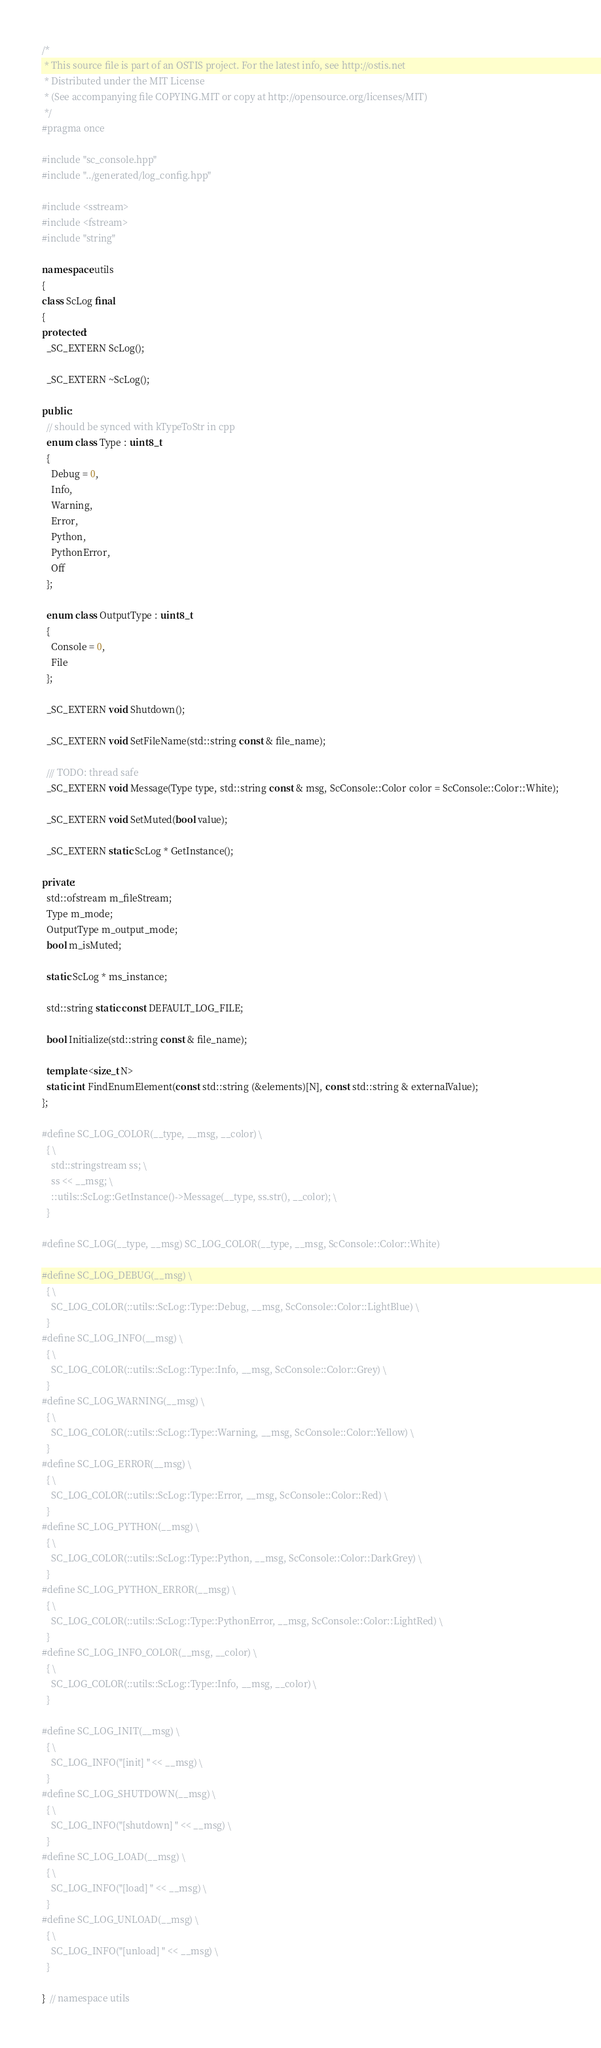<code> <loc_0><loc_0><loc_500><loc_500><_C++_>/*
 * This source file is part of an OSTIS project. For the latest info, see http://ostis.net
 * Distributed under the MIT License
 * (See accompanying file COPYING.MIT or copy at http://opensource.org/licenses/MIT)
 */
#pragma once

#include "sc_console.hpp"
#include "../generated/log_config.hpp"

#include <sstream>
#include <fstream>
#include "string"

namespace utils
{
class ScLog final
{
protected:
  _SC_EXTERN ScLog();

  _SC_EXTERN ~ScLog();

public:
  // should be synced with kTypeToStr in cpp
  enum class Type : uint8_t
  {
    Debug = 0,
    Info,
    Warning,
    Error,
    Python,
    PythonError,
    Off
  };

  enum class OutputType : uint8_t
  {
    Console = 0,
    File
  };

  _SC_EXTERN void Shutdown();

  _SC_EXTERN void SetFileName(std::string const & file_name);

  /// TODO: thread safe
  _SC_EXTERN void Message(Type type, std::string const & msg, ScConsole::Color color = ScConsole::Color::White);

  _SC_EXTERN void SetMuted(bool value);

  _SC_EXTERN static ScLog * GetInstance();

private:
  std::ofstream m_fileStream;
  Type m_mode;
  OutputType m_output_mode;
  bool m_isMuted;

  static ScLog * ms_instance;

  std::string static const DEFAULT_LOG_FILE;

  bool Initialize(std::string const & file_name);

  template <size_t N>
  static int FindEnumElement(const std::string (&elements)[N], const std::string & externalValue);
};

#define SC_LOG_COLOR(__type, __msg, __color) \
  { \
    std::stringstream ss; \
    ss << __msg; \
    ::utils::ScLog::GetInstance()->Message(__type, ss.str(), __color); \
  }

#define SC_LOG(__type, __msg) SC_LOG_COLOR(__type, __msg, ScConsole::Color::White)

#define SC_LOG_DEBUG(__msg) \
  { \
    SC_LOG_COLOR(::utils::ScLog::Type::Debug, __msg, ScConsole::Color::LightBlue) \
  }
#define SC_LOG_INFO(__msg) \
  { \
    SC_LOG_COLOR(::utils::ScLog::Type::Info, __msg, ScConsole::Color::Grey) \
  }
#define SC_LOG_WARNING(__msg) \
  { \
    SC_LOG_COLOR(::utils::ScLog::Type::Warning, __msg, ScConsole::Color::Yellow) \
  }
#define SC_LOG_ERROR(__msg) \
  { \
    SC_LOG_COLOR(::utils::ScLog::Type::Error, __msg, ScConsole::Color::Red) \
  }
#define SC_LOG_PYTHON(__msg) \
  { \
    SC_LOG_COLOR(::utils::ScLog::Type::Python, __msg, ScConsole::Color::DarkGrey) \
  }
#define SC_LOG_PYTHON_ERROR(__msg) \
  { \
    SC_LOG_COLOR(::utils::ScLog::Type::PythonError, __msg, ScConsole::Color::LightRed) \
  }
#define SC_LOG_INFO_COLOR(__msg, __color) \
  { \
    SC_LOG_COLOR(::utils::ScLog::Type::Info, __msg, __color) \
  }

#define SC_LOG_INIT(__msg) \
  { \
    SC_LOG_INFO("[init] " << __msg) \
  }
#define SC_LOG_SHUTDOWN(__msg) \
  { \
    SC_LOG_INFO("[shutdown] " << __msg) \
  }
#define SC_LOG_LOAD(__msg) \
  { \
    SC_LOG_INFO("[load] " << __msg) \
  }
#define SC_LOG_UNLOAD(__msg) \
  { \
    SC_LOG_INFO("[unload] " << __msg) \
  }

}  // namespace utils
</code> 